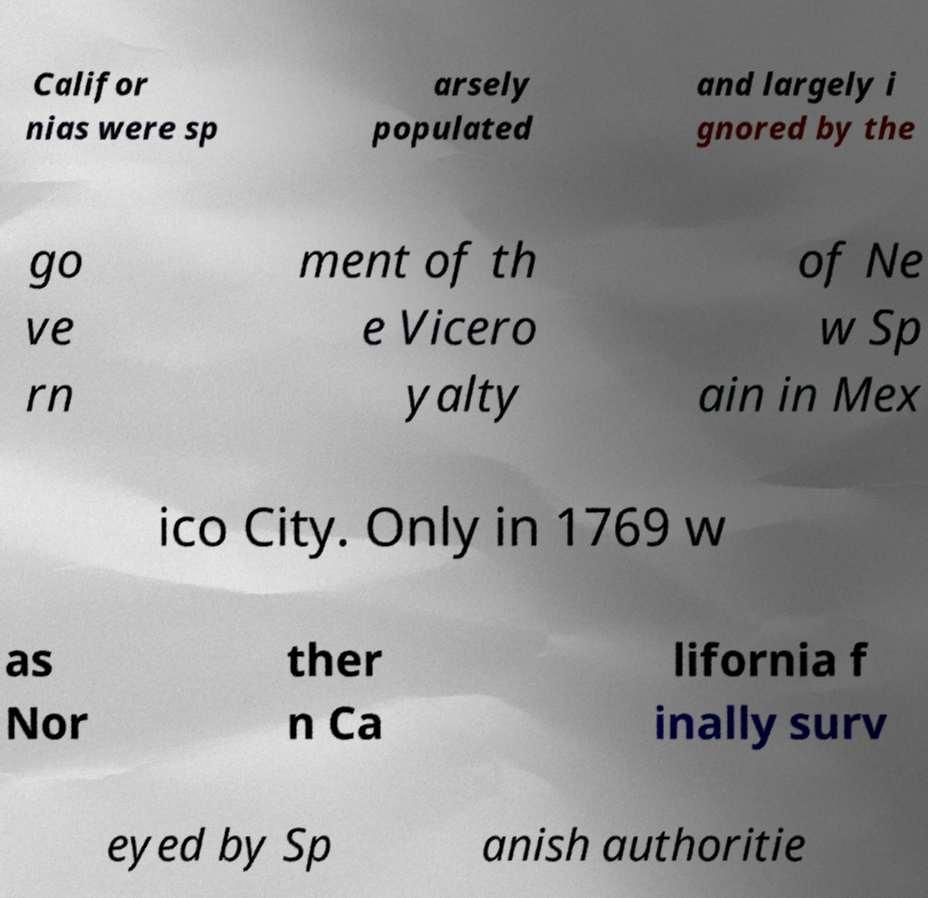Can you accurately transcribe the text from the provided image for me? Califor nias were sp arsely populated and largely i gnored by the go ve rn ment of th e Vicero yalty of Ne w Sp ain in Mex ico City. Only in 1769 w as Nor ther n Ca lifornia f inally surv eyed by Sp anish authoritie 